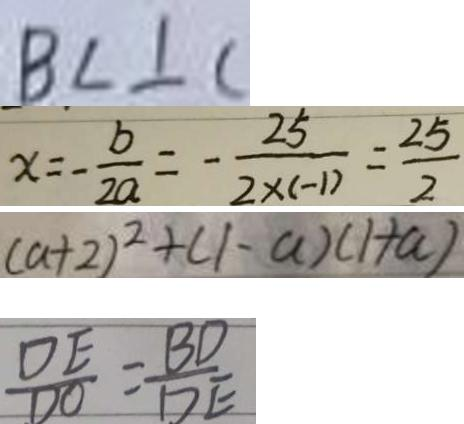<formula> <loc_0><loc_0><loc_500><loc_500>B C \bot C 
 x = - \frac { b } { 2 a } = - \frac { 2 5 } { 2 \times ( - 1 ) } = \frac { 2 5 } { 2 } 
 ( a + 2 ) ^ { 2 } + ( 1 - a ) ( 1 + a ) 
 \frac { D E } { D O } = \frac { B D } { D E }</formula> 